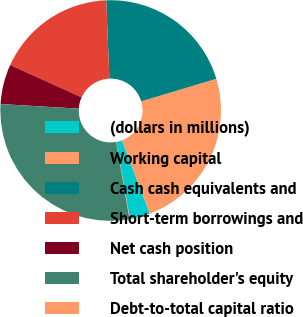Convert chart to OTSL. <chart><loc_0><loc_0><loc_500><loc_500><pie_chart><fcel>(dollars in millions)<fcel>Working capital<fcel>Cash cash equivalents and<fcel>Short-term borrowings and<fcel>Net cash position<fcel>Total shareholder's equity<fcel>Debt-to-total capital ratio<nl><fcel>2.97%<fcel>23.87%<fcel>21.0%<fcel>17.59%<fcel>5.83%<fcel>28.68%<fcel>0.06%<nl></chart> 